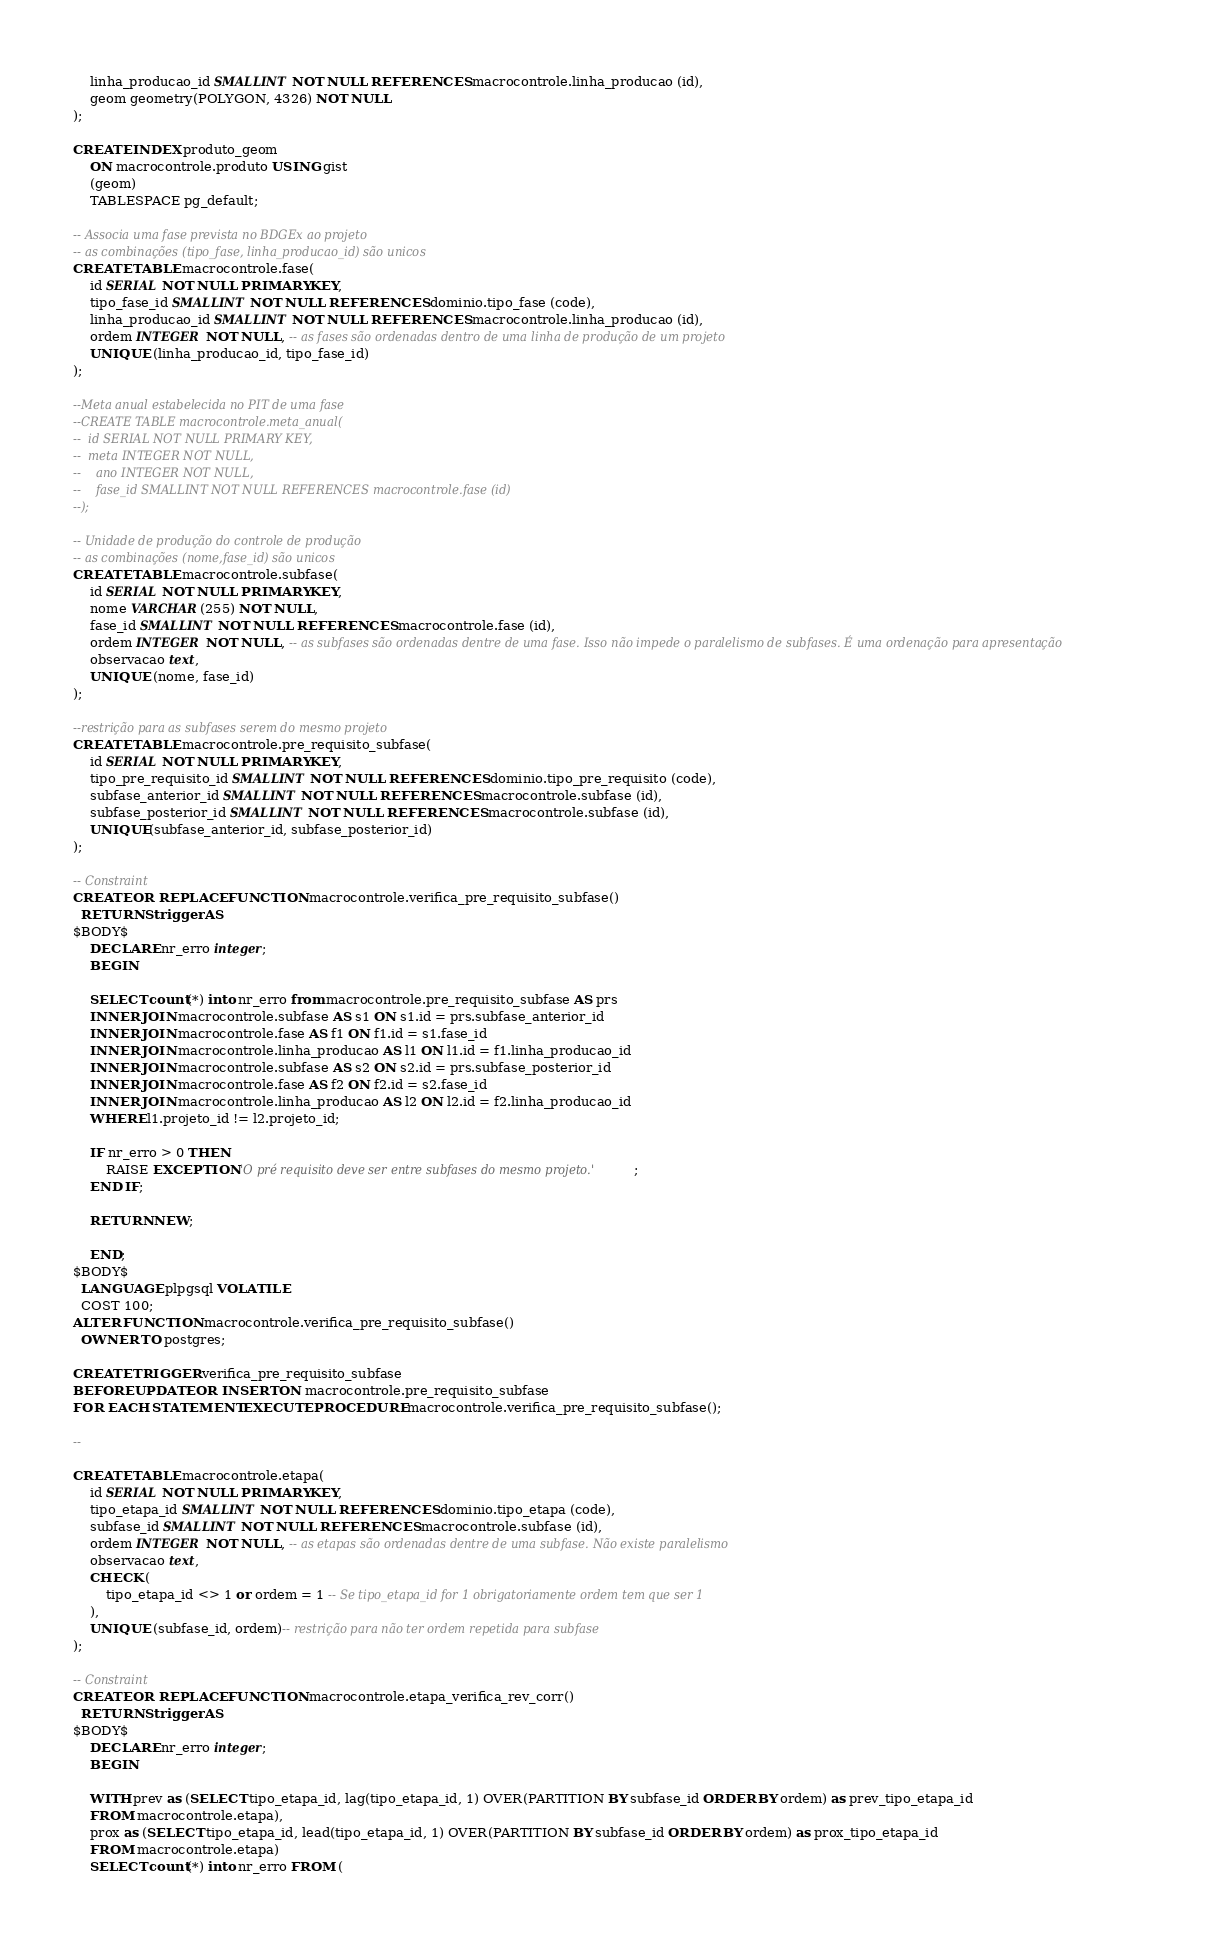<code> <loc_0><loc_0><loc_500><loc_500><_SQL_>	linha_producao_id SMALLINT NOT NULL REFERENCES macrocontrole.linha_producao (id),
	geom geometry(POLYGON, 4326) NOT NULL
);

CREATE INDEX produto_geom
    ON macrocontrole.produto USING gist
    (geom)
    TABLESPACE pg_default;

-- Associa uma fase prevista no BDGEx ao projeto
-- as combinações (tipo_fase, linha_producao_id) são unicos
CREATE TABLE macrocontrole.fase(
    id SERIAL NOT NULL PRIMARY KEY,
    tipo_fase_id SMALLINT NOT NULL REFERENCES dominio.tipo_fase (code),
    linha_producao_id SMALLINT NOT NULL REFERENCES macrocontrole.linha_producao (id),
    ordem INTEGER NOT NULL, -- as fases são ordenadas dentro de uma linha de produção de um projeto
    UNIQUE (linha_producao_id, tipo_fase_id)
);

--Meta anual estabelecida no PIT de uma fase
--CREATE TABLE macrocontrole.meta_anual(
--	id SERIAL NOT NULL PRIMARY KEY,
--	meta INTEGER NOT NULL,
--    ano INTEGER NOT NULL,
--    fase_id SMALLINT NOT NULL REFERENCES macrocontrole.fase (id)
--);

-- Unidade de produção do controle de produção
-- as combinações (nome,fase_id) são unicos
CREATE TABLE macrocontrole.subfase(
	id SERIAL NOT NULL PRIMARY KEY,
	nome VARCHAR(255) NOT NULL,
	fase_id SMALLINT NOT NULL REFERENCES macrocontrole.fase (id),
	ordem INTEGER NOT NULL, -- as subfases são ordenadas dentre de uma fase. Isso não impede o paralelismo de subfases. É uma ordenação para apresentação
	observacao text,
	UNIQUE (nome, fase_id)
);

--restrição para as subfases serem do mesmo projeto
CREATE TABLE macrocontrole.pre_requisito_subfase(
	id SERIAL NOT NULL PRIMARY KEY,
	tipo_pre_requisito_id SMALLINT NOT NULL REFERENCES dominio.tipo_pre_requisito (code),
	subfase_anterior_id SMALLINT NOT NULL REFERENCES macrocontrole.subfase (id),
	subfase_posterior_id SMALLINT NOT NULL REFERENCES macrocontrole.subfase (id),
	UNIQUE(subfase_anterior_id, subfase_posterior_id)
);

-- Constraint
CREATE OR REPLACE FUNCTION macrocontrole.verifica_pre_requisito_subfase()
  RETURNS trigger AS
$BODY$
    DECLARE nr_erro integer;
    BEGIN

	SELECT count(*) into nr_erro from macrocontrole.pre_requisito_subfase AS prs
	INNER JOIN macrocontrole.subfase AS s1 ON s1.id = prs.subfase_anterior_id
	INNER JOIN macrocontrole.fase AS f1 ON f1.id = s1.fase_id
	INNER JOIN macrocontrole.linha_producao AS l1 ON l1.id = f1.linha_producao_id
	INNER JOIN macrocontrole.subfase AS s2 ON s2.id = prs.subfase_posterior_id
	INNER JOIN macrocontrole.fase AS f2 ON f2.id = s2.fase_id
	INNER JOIN macrocontrole.linha_producao AS l2 ON l2.id = f2.linha_producao_id
	WHERE l1.projeto_id != l2.projeto_id;

	IF nr_erro > 0 THEN
		RAISE EXCEPTION 'O pré requisito deve ser entre subfases do mesmo projeto.';
	END IF;

	RETURN NEW;

    END;
$BODY$
  LANGUAGE plpgsql VOLATILE
  COST 100;
ALTER FUNCTION macrocontrole.verifica_pre_requisito_subfase()
  OWNER TO postgres;

CREATE TRIGGER verifica_pre_requisito_subfase
BEFORE UPDATE OR INSERT ON macrocontrole.pre_requisito_subfase
FOR EACH STATEMENT EXECUTE PROCEDURE macrocontrole.verifica_pre_requisito_subfase();

--

CREATE TABLE macrocontrole.etapa(
	id SERIAL NOT NULL PRIMARY KEY,
	tipo_etapa_id SMALLINT NOT NULL REFERENCES dominio.tipo_etapa (code),
	subfase_id SMALLINT NOT NULL REFERENCES macrocontrole.subfase (id),
	ordem INTEGER NOT NULL, -- as etapas são ordenadas dentre de uma subfase. Não existe paralelismo
	observacao text,
	CHECK (
		tipo_etapa_id <> 1 or ordem = 1 -- Se tipo_etapa_id for 1 obrigatoriamente ordem tem que ser 1
	),
	UNIQUE (subfase_id, ordem)-- restrição para não ter ordem repetida para subfase
);

-- Constraint
CREATE OR REPLACE FUNCTION macrocontrole.etapa_verifica_rev_corr()
  RETURNS trigger AS
$BODY$
    DECLARE nr_erro integer;
    BEGIN

	WITH prev as (SELECT tipo_etapa_id, lag(tipo_etapa_id, 1) OVER(PARTITION BY subfase_id ORDER BY ordem) as prev_tipo_etapa_id
	FROM macrocontrole.etapa),
	prox as (SELECT tipo_etapa_id, lead(tipo_etapa_id, 1) OVER(PARTITION BY subfase_id ORDER BY ordem) as prox_tipo_etapa_id
	FROM macrocontrole.etapa)
	SELECT count(*) into nr_erro FROM (</code> 